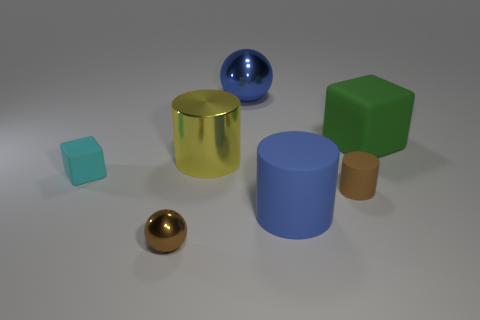Add 1 green things. How many objects exist? 8 Subtract all blocks. How many objects are left? 5 Subtract all small yellow rubber cylinders. Subtract all green things. How many objects are left? 6 Add 1 big yellow cylinders. How many big yellow cylinders are left? 2 Add 6 green things. How many green things exist? 7 Subtract 0 red balls. How many objects are left? 7 